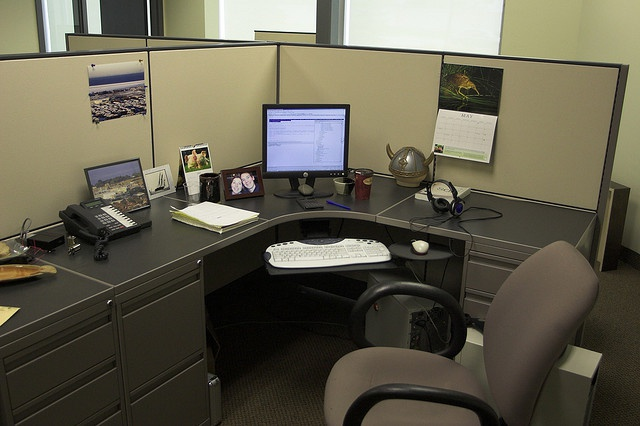Describe the objects in this image and their specific colors. I can see chair in gray and black tones, tv in gray, lavender, and black tones, keyboard in gray, beige, lightgray, and darkgray tones, book in gray, ivory, olive, and black tones, and cup in gray and black tones in this image. 